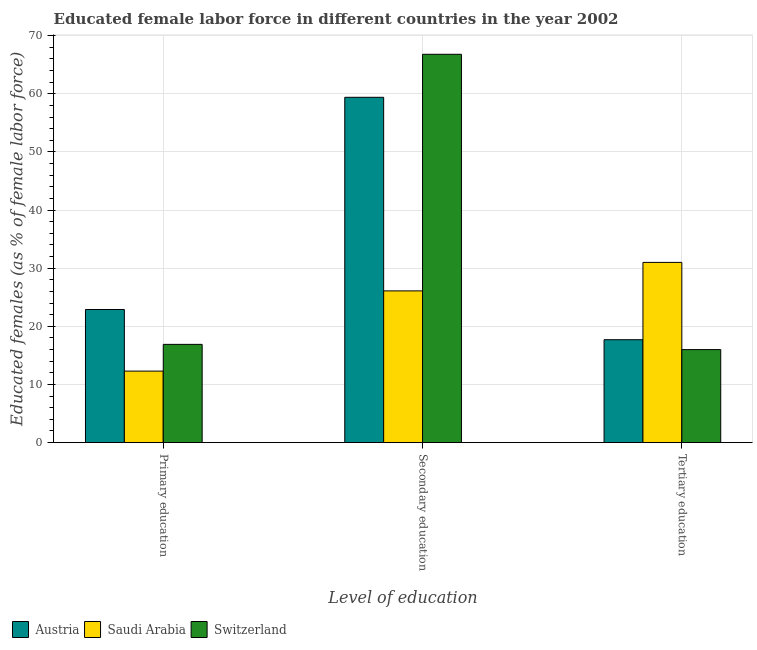How many different coloured bars are there?
Make the answer very short. 3. How many groups of bars are there?
Your answer should be compact. 3. Are the number of bars per tick equal to the number of legend labels?
Offer a terse response. Yes. How many bars are there on the 3rd tick from the left?
Make the answer very short. 3. What is the label of the 2nd group of bars from the left?
Your answer should be compact. Secondary education. What is the percentage of female labor force who received secondary education in Austria?
Ensure brevity in your answer.  59.4. Across all countries, what is the maximum percentage of female labor force who received secondary education?
Keep it short and to the point. 66.8. Across all countries, what is the minimum percentage of female labor force who received primary education?
Give a very brief answer. 12.3. In which country was the percentage of female labor force who received tertiary education maximum?
Your answer should be compact. Saudi Arabia. In which country was the percentage of female labor force who received tertiary education minimum?
Provide a succinct answer. Switzerland. What is the total percentage of female labor force who received secondary education in the graph?
Your answer should be compact. 152.3. What is the difference between the percentage of female labor force who received secondary education in Switzerland and that in Austria?
Make the answer very short. 7.4. What is the difference between the percentage of female labor force who received secondary education in Switzerland and the percentage of female labor force who received tertiary education in Austria?
Offer a very short reply. 49.1. What is the average percentage of female labor force who received tertiary education per country?
Ensure brevity in your answer.  21.57. What is the difference between the percentage of female labor force who received primary education and percentage of female labor force who received secondary education in Austria?
Make the answer very short. -36.5. In how many countries, is the percentage of female labor force who received tertiary education greater than 32 %?
Your answer should be compact. 0. What is the ratio of the percentage of female labor force who received primary education in Austria to that in Switzerland?
Give a very brief answer. 1.36. Is the percentage of female labor force who received secondary education in Austria less than that in Saudi Arabia?
Offer a very short reply. No. What is the difference between the highest and the second highest percentage of female labor force who received secondary education?
Give a very brief answer. 7.4. What is the difference between the highest and the lowest percentage of female labor force who received secondary education?
Your answer should be compact. 40.7. What does the 1st bar from the left in Primary education represents?
Give a very brief answer. Austria. What does the 3rd bar from the right in Primary education represents?
Give a very brief answer. Austria. How many bars are there?
Make the answer very short. 9. Are all the bars in the graph horizontal?
Provide a short and direct response. No. What is the difference between two consecutive major ticks on the Y-axis?
Give a very brief answer. 10. Where does the legend appear in the graph?
Ensure brevity in your answer.  Bottom left. How many legend labels are there?
Offer a very short reply. 3. What is the title of the graph?
Your answer should be compact. Educated female labor force in different countries in the year 2002. What is the label or title of the X-axis?
Keep it short and to the point. Level of education. What is the label or title of the Y-axis?
Offer a terse response. Educated females (as % of female labor force). What is the Educated females (as % of female labor force) in Austria in Primary education?
Ensure brevity in your answer.  22.9. What is the Educated females (as % of female labor force) in Saudi Arabia in Primary education?
Give a very brief answer. 12.3. What is the Educated females (as % of female labor force) in Switzerland in Primary education?
Provide a short and direct response. 16.9. What is the Educated females (as % of female labor force) in Austria in Secondary education?
Offer a terse response. 59.4. What is the Educated females (as % of female labor force) of Saudi Arabia in Secondary education?
Keep it short and to the point. 26.1. What is the Educated females (as % of female labor force) of Switzerland in Secondary education?
Provide a succinct answer. 66.8. What is the Educated females (as % of female labor force) of Austria in Tertiary education?
Your answer should be compact. 17.7. What is the Educated females (as % of female labor force) in Switzerland in Tertiary education?
Provide a succinct answer. 16. Across all Level of education, what is the maximum Educated females (as % of female labor force) of Austria?
Make the answer very short. 59.4. Across all Level of education, what is the maximum Educated females (as % of female labor force) of Saudi Arabia?
Your answer should be very brief. 31. Across all Level of education, what is the maximum Educated females (as % of female labor force) of Switzerland?
Ensure brevity in your answer.  66.8. Across all Level of education, what is the minimum Educated females (as % of female labor force) of Austria?
Your answer should be compact. 17.7. Across all Level of education, what is the minimum Educated females (as % of female labor force) in Saudi Arabia?
Provide a short and direct response. 12.3. What is the total Educated females (as % of female labor force) of Austria in the graph?
Your response must be concise. 100. What is the total Educated females (as % of female labor force) of Saudi Arabia in the graph?
Ensure brevity in your answer.  69.4. What is the total Educated females (as % of female labor force) of Switzerland in the graph?
Offer a very short reply. 99.7. What is the difference between the Educated females (as % of female labor force) of Austria in Primary education and that in Secondary education?
Offer a very short reply. -36.5. What is the difference between the Educated females (as % of female labor force) of Saudi Arabia in Primary education and that in Secondary education?
Your answer should be compact. -13.8. What is the difference between the Educated females (as % of female labor force) in Switzerland in Primary education and that in Secondary education?
Ensure brevity in your answer.  -49.9. What is the difference between the Educated females (as % of female labor force) in Saudi Arabia in Primary education and that in Tertiary education?
Your response must be concise. -18.7. What is the difference between the Educated females (as % of female labor force) in Austria in Secondary education and that in Tertiary education?
Your response must be concise. 41.7. What is the difference between the Educated females (as % of female labor force) of Saudi Arabia in Secondary education and that in Tertiary education?
Offer a very short reply. -4.9. What is the difference between the Educated females (as % of female labor force) in Switzerland in Secondary education and that in Tertiary education?
Provide a short and direct response. 50.8. What is the difference between the Educated females (as % of female labor force) of Austria in Primary education and the Educated females (as % of female labor force) of Switzerland in Secondary education?
Your answer should be very brief. -43.9. What is the difference between the Educated females (as % of female labor force) in Saudi Arabia in Primary education and the Educated females (as % of female labor force) in Switzerland in Secondary education?
Your answer should be very brief. -54.5. What is the difference between the Educated females (as % of female labor force) in Austria in Primary education and the Educated females (as % of female labor force) in Saudi Arabia in Tertiary education?
Give a very brief answer. -8.1. What is the difference between the Educated females (as % of female labor force) in Austria in Primary education and the Educated females (as % of female labor force) in Switzerland in Tertiary education?
Make the answer very short. 6.9. What is the difference between the Educated females (as % of female labor force) of Austria in Secondary education and the Educated females (as % of female labor force) of Saudi Arabia in Tertiary education?
Keep it short and to the point. 28.4. What is the difference between the Educated females (as % of female labor force) of Austria in Secondary education and the Educated females (as % of female labor force) of Switzerland in Tertiary education?
Offer a very short reply. 43.4. What is the difference between the Educated females (as % of female labor force) in Saudi Arabia in Secondary education and the Educated females (as % of female labor force) in Switzerland in Tertiary education?
Give a very brief answer. 10.1. What is the average Educated females (as % of female labor force) of Austria per Level of education?
Provide a short and direct response. 33.33. What is the average Educated females (as % of female labor force) in Saudi Arabia per Level of education?
Make the answer very short. 23.13. What is the average Educated females (as % of female labor force) in Switzerland per Level of education?
Offer a terse response. 33.23. What is the difference between the Educated females (as % of female labor force) in Austria and Educated females (as % of female labor force) in Saudi Arabia in Primary education?
Your answer should be compact. 10.6. What is the difference between the Educated females (as % of female labor force) in Austria and Educated females (as % of female labor force) in Switzerland in Primary education?
Your answer should be compact. 6. What is the difference between the Educated females (as % of female labor force) of Austria and Educated females (as % of female labor force) of Saudi Arabia in Secondary education?
Offer a terse response. 33.3. What is the difference between the Educated females (as % of female labor force) in Austria and Educated females (as % of female labor force) in Switzerland in Secondary education?
Keep it short and to the point. -7.4. What is the difference between the Educated females (as % of female labor force) in Saudi Arabia and Educated females (as % of female labor force) in Switzerland in Secondary education?
Provide a short and direct response. -40.7. What is the difference between the Educated females (as % of female labor force) of Austria and Educated females (as % of female labor force) of Saudi Arabia in Tertiary education?
Your response must be concise. -13.3. What is the ratio of the Educated females (as % of female labor force) in Austria in Primary education to that in Secondary education?
Keep it short and to the point. 0.39. What is the ratio of the Educated females (as % of female labor force) in Saudi Arabia in Primary education to that in Secondary education?
Provide a succinct answer. 0.47. What is the ratio of the Educated females (as % of female labor force) of Switzerland in Primary education to that in Secondary education?
Provide a short and direct response. 0.25. What is the ratio of the Educated females (as % of female labor force) in Austria in Primary education to that in Tertiary education?
Keep it short and to the point. 1.29. What is the ratio of the Educated females (as % of female labor force) in Saudi Arabia in Primary education to that in Tertiary education?
Your answer should be compact. 0.4. What is the ratio of the Educated females (as % of female labor force) in Switzerland in Primary education to that in Tertiary education?
Provide a succinct answer. 1.06. What is the ratio of the Educated females (as % of female labor force) in Austria in Secondary education to that in Tertiary education?
Keep it short and to the point. 3.36. What is the ratio of the Educated females (as % of female labor force) in Saudi Arabia in Secondary education to that in Tertiary education?
Your response must be concise. 0.84. What is the ratio of the Educated females (as % of female labor force) in Switzerland in Secondary education to that in Tertiary education?
Your response must be concise. 4.17. What is the difference between the highest and the second highest Educated females (as % of female labor force) in Austria?
Make the answer very short. 36.5. What is the difference between the highest and the second highest Educated females (as % of female labor force) in Saudi Arabia?
Your response must be concise. 4.9. What is the difference between the highest and the second highest Educated females (as % of female labor force) of Switzerland?
Your answer should be compact. 49.9. What is the difference between the highest and the lowest Educated females (as % of female labor force) of Austria?
Your answer should be very brief. 41.7. What is the difference between the highest and the lowest Educated females (as % of female labor force) in Switzerland?
Give a very brief answer. 50.8. 